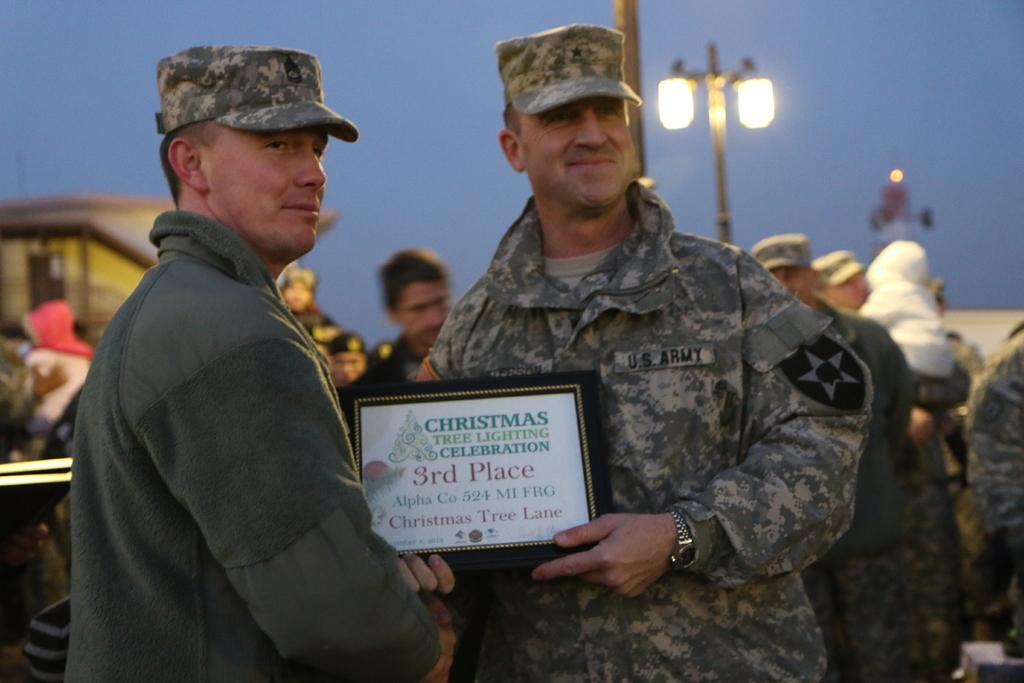What are the two men in the image doing? The two men in the image are standing and smiling. What are the men holding in the image? The men are holding a photo frame. What can be seen in the background of the image? There is a light pole in the image. How many people are present in the image? There are people standing in the image. What is visible in the sky in the image? The sky is visible in the image. What type of mountain can be seen in the background of the image? There is no mountain visible in the image; it only shows two men standing and smiling, holding a photo frame, and a light pole in the background. 